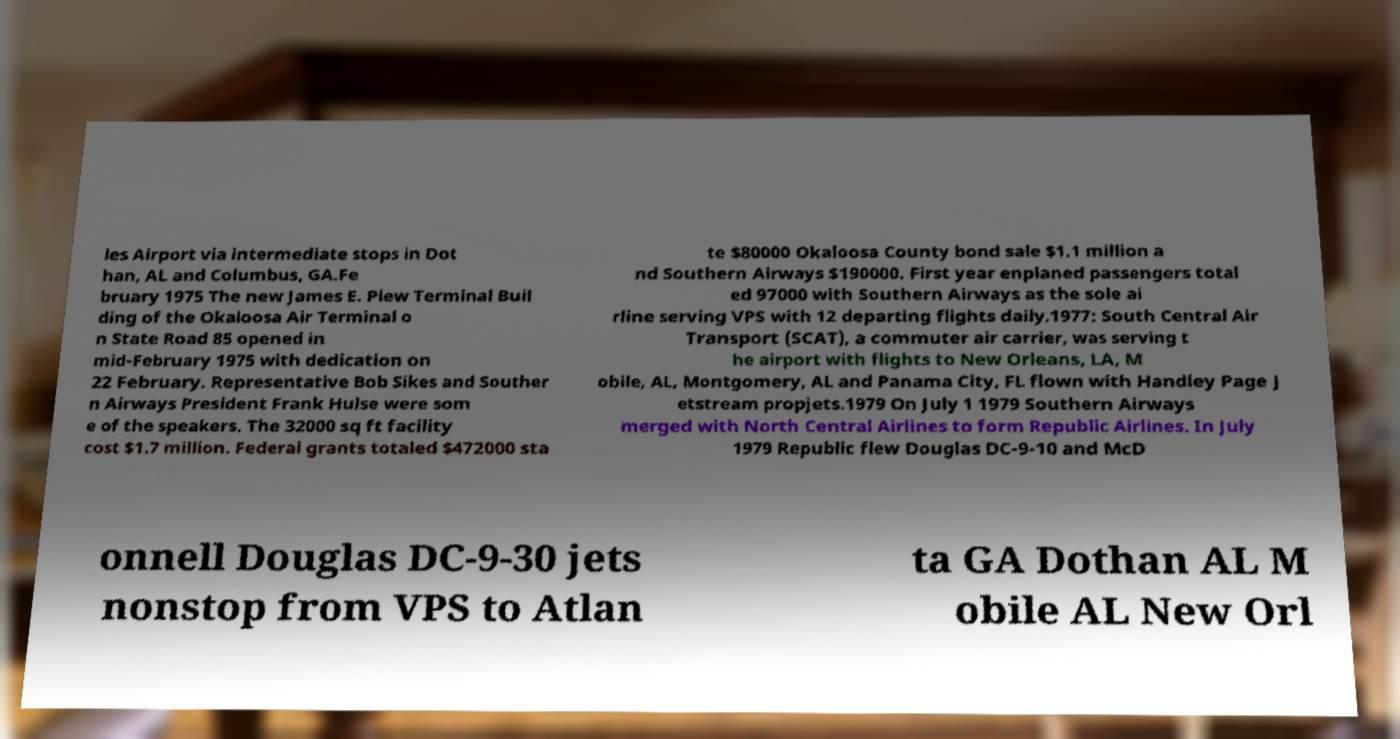Can you read and provide the text displayed in the image?This photo seems to have some interesting text. Can you extract and type it out for me? les Airport via intermediate stops in Dot han, AL and Columbus, GA.Fe bruary 1975 The new James E. Plew Terminal Buil ding of the Okaloosa Air Terminal o n State Road 85 opened in mid-February 1975 with dedication on 22 February. Representative Bob Sikes and Souther n Airways President Frank Hulse were som e of the speakers. The 32000 sq ft facility cost $1.7 million. Federal grants totaled $472000 sta te $80000 Okaloosa County bond sale $1.1 million a nd Southern Airways $190000. First year enplaned passengers total ed 97000 with Southern Airways as the sole ai rline serving VPS with 12 departing flights daily.1977: South Central Air Transport (SCAT), a commuter air carrier, was serving t he airport with flights to New Orleans, LA, M obile, AL, Montgomery, AL and Panama City, FL flown with Handley Page J etstream propjets.1979 On July 1 1979 Southern Airways merged with North Central Airlines to form Republic Airlines. In July 1979 Republic flew Douglas DC-9-10 and McD onnell Douglas DC-9-30 jets nonstop from VPS to Atlan ta GA Dothan AL M obile AL New Orl 